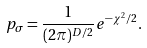Convert formula to latex. <formula><loc_0><loc_0><loc_500><loc_500>p _ { \sigma } = \frac { 1 } { ( 2 \pi ) ^ { D / 2 } } e ^ { - \chi ^ { 2 } / 2 } .</formula> 